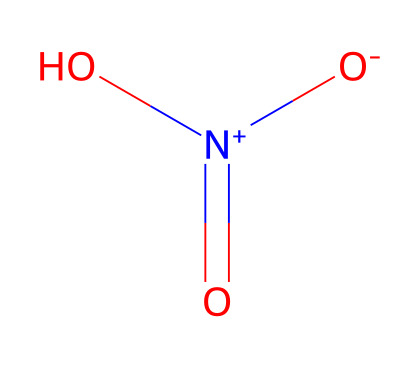What is the name of this chemical? The SMILES representation O=[N+]([O-])O corresponds to nitric acid, which is a well-known acid commonly used in various applications.
Answer: nitric acid How many oxygen atoms are present in this molecule? Analyzing the SMILES structure, we can identify three oxygen atoms: one double-bonded to nitrogen, and two bonded to nitrogen in a single bond, one of which carries a negative charge.
Answer: three What is the oxidation state of the nitrogen atom in this acid? In the chemical structure, the nitrogen atom is bonded to two oxygen atoms, one through a double bond and the other through a single bond while also holding a positive charge, indicating a +5 oxidation state.
Answer: +5 Which type of bond connects the nitrogen to the oxygen that has a negative charge? The nitrogen is connected to one of the oxygen atoms by a single bond, which allows for the oxygen to carry a negative charge as a result of the electron configuration.
Answer: single bond What type of acid is nitric acid classified as? Given the structure and functional groups present, nitric acid is classified as a strong acid due to its complete ionization in water and high dissociation.
Answer: strong acid Which functional group is present in this molecule? The presence of a nitrogen atom bonded to oxygen atoms and facilitates hydrogen ion donation is indicative of the carboxylic acid functional group.
Answer: carboxylic acid What is the charge on the nitrogen atom in this compound? The nitrogen atom in the SMILES structure is depicted as positive due to its connection to the singly bonded negative oxygen, resulting in an overall charge of +1.
Answer: +1 